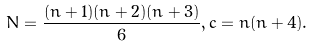<formula> <loc_0><loc_0><loc_500><loc_500>N = \frac { ( n + 1 ) ( n + 2 ) ( n + 3 ) } { 6 } , c = n ( n + 4 ) .</formula> 